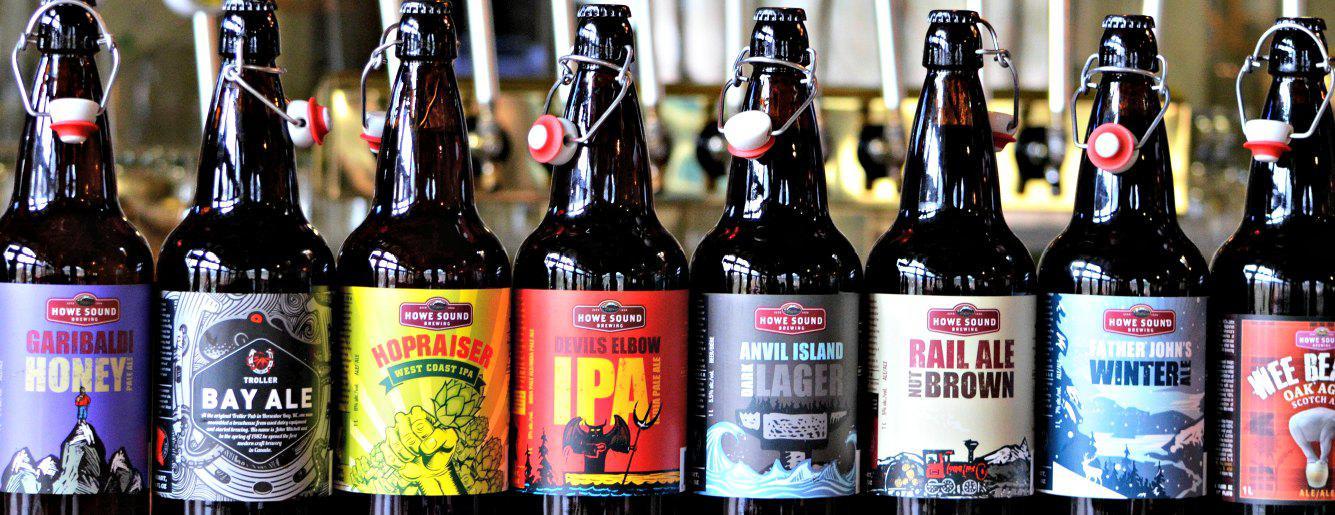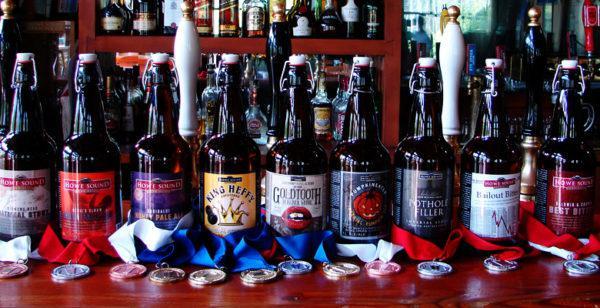The first image is the image on the left, the second image is the image on the right. For the images shown, is this caption "There are two levels of beer bottles." true? Answer yes or no. No. 